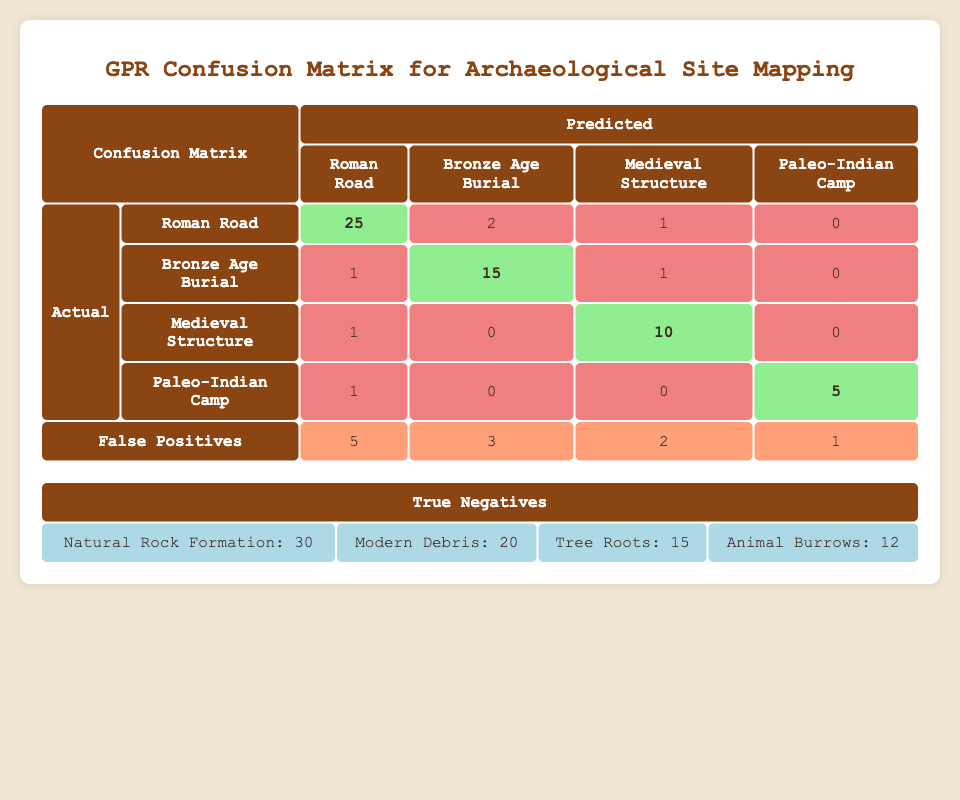What is the total number of true positives for the Roman Road? The table shows that there are 25 true positives for the Roman Road.
Answer: 25 How many false negatives were identified for the Bronze Age Burial? The table indicates there are 2 false negatives for the Bronze Age Burial.
Answer: 2 What is the total number of false positives across all archaeological features? By adding the false positives: 5 (Roman Road) + 3 (Bronze Age Burial) + 2 (Medieval Structure) + 1 (Paleo-Indian Camp) = 11.
Answer: 11 Are there any false positives for the Paleo-Indian Camp? The table shows that there is 1 false positive for the Paleo-Indian Camp, which confirms the occurrence of false positives for this feature.
Answer: Yes Which archaeological feature has the highest number of true negatives? The true negatives for Natural Rock Formation are 30, which is the highest compared to the other features (Modern Debris: 20, Tree Roots: 15, Animal Burrows: 12).
Answer: Natural Rock Formation What is the difference between the number of true positives and false negatives for the Medieval Structure? The true positives for the Medieval Structure are 10 and false negatives are 1. The difference is 10 - 1 = 9.
Answer: 9 What percentage of Roman Road identifications were false positives? There are 5 false positives and 25 true positives for the Roman Road. The total identified is 25 + 5 = 30. The percentage of false positives is (5 / 30) * 100 = 16.67%.
Answer: 16.67% Which archaeological feature had the least number of false negatives? By comparing the false negatives, the Paleo-Indian Camp and Medieval Structure both have 1 false negative, but since the Medieval Structure has a higher total count of true positives, we consider the Paleo-Indian Camp here due to its ranking in the confusion matrix where mentioned.
Answer: Paleo-Indian Camp What is the total number of true negatives recorded in the confusion matrix? Adding all true negative values together gives: 30 (Natural Rock Formation) + 20 (Modern Debris) + 15 (Tree Roots) + 12 (Animal Burrows) = 77.
Answer: 77 